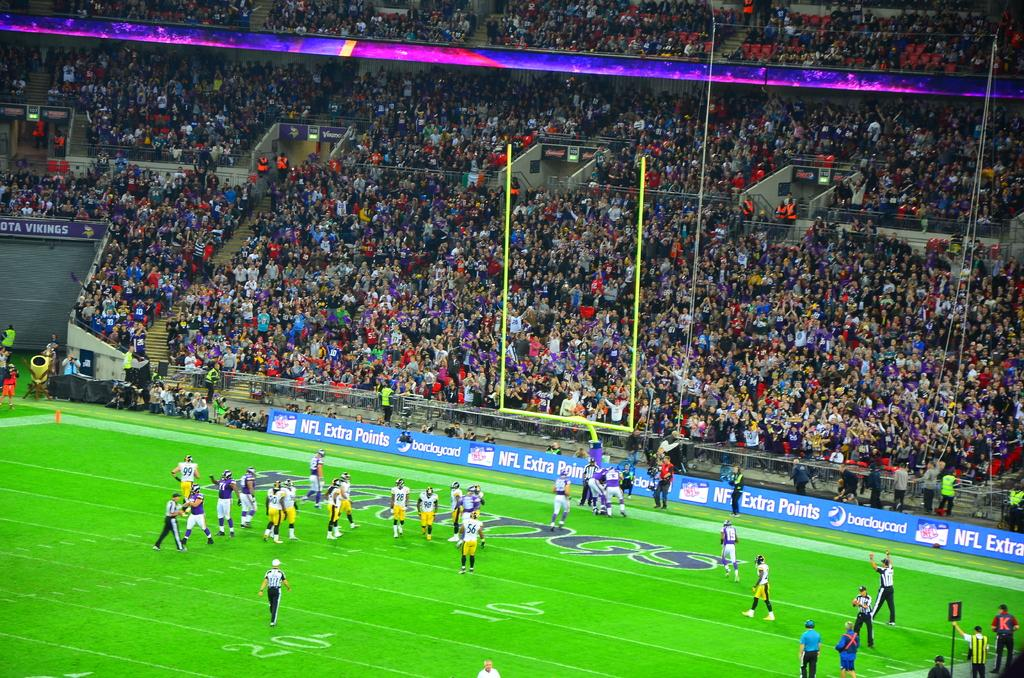Provide a one-sentence caption for the provided image. A football game with barclaycard ads played on the tickers. 